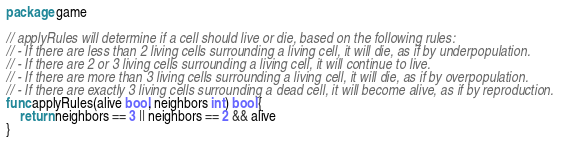<code> <loc_0><loc_0><loc_500><loc_500><_Go_>package game

// applyRules will determine if a cell should live or die, based on the following rules:
// - If there are less than 2 living cells surrounding a living cell, it will die, as if by underpopulation.
// - If there are 2 or 3 living cells surrounding a living cell, it will continue to live.
// - If there are more than 3 living cells surrounding a living cell, it will die, as if by overpopulation.
// - If there are exactly 3 living cells surrounding a dead cell, it will become alive, as if by reproduction.
func applyRules(alive bool, neighbors int) bool {
	return neighbors == 3 || neighbors == 2 && alive
}
</code> 